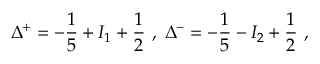<formula> <loc_0><loc_0><loc_500><loc_500>\Delta ^ { + } = - \frac { 1 } { 5 } + I _ { 1 } + \frac { 1 } { 2 } \, , \, \Delta ^ { - } = - \frac { 1 } { 5 } - I _ { 2 } + \frac { 1 } { 2 } \, ,</formula> 